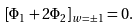Convert formula to latex. <formula><loc_0><loc_0><loc_500><loc_500>\left [ \Phi _ { 1 } + 2 \Phi _ { 2 } \right ] _ { w = \pm 1 } = 0 .</formula> 